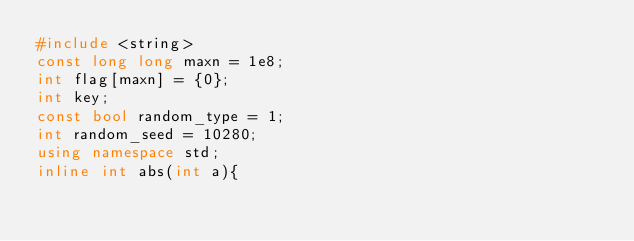Convert code to text. <code><loc_0><loc_0><loc_500><loc_500><_C++_>#include <string>
const long long maxn = 1e8;
int flag[maxn] = {0};
int key;
const bool random_type = 1;
int random_seed = 10280;
using namespace std;
inline int abs(int a){</code> 